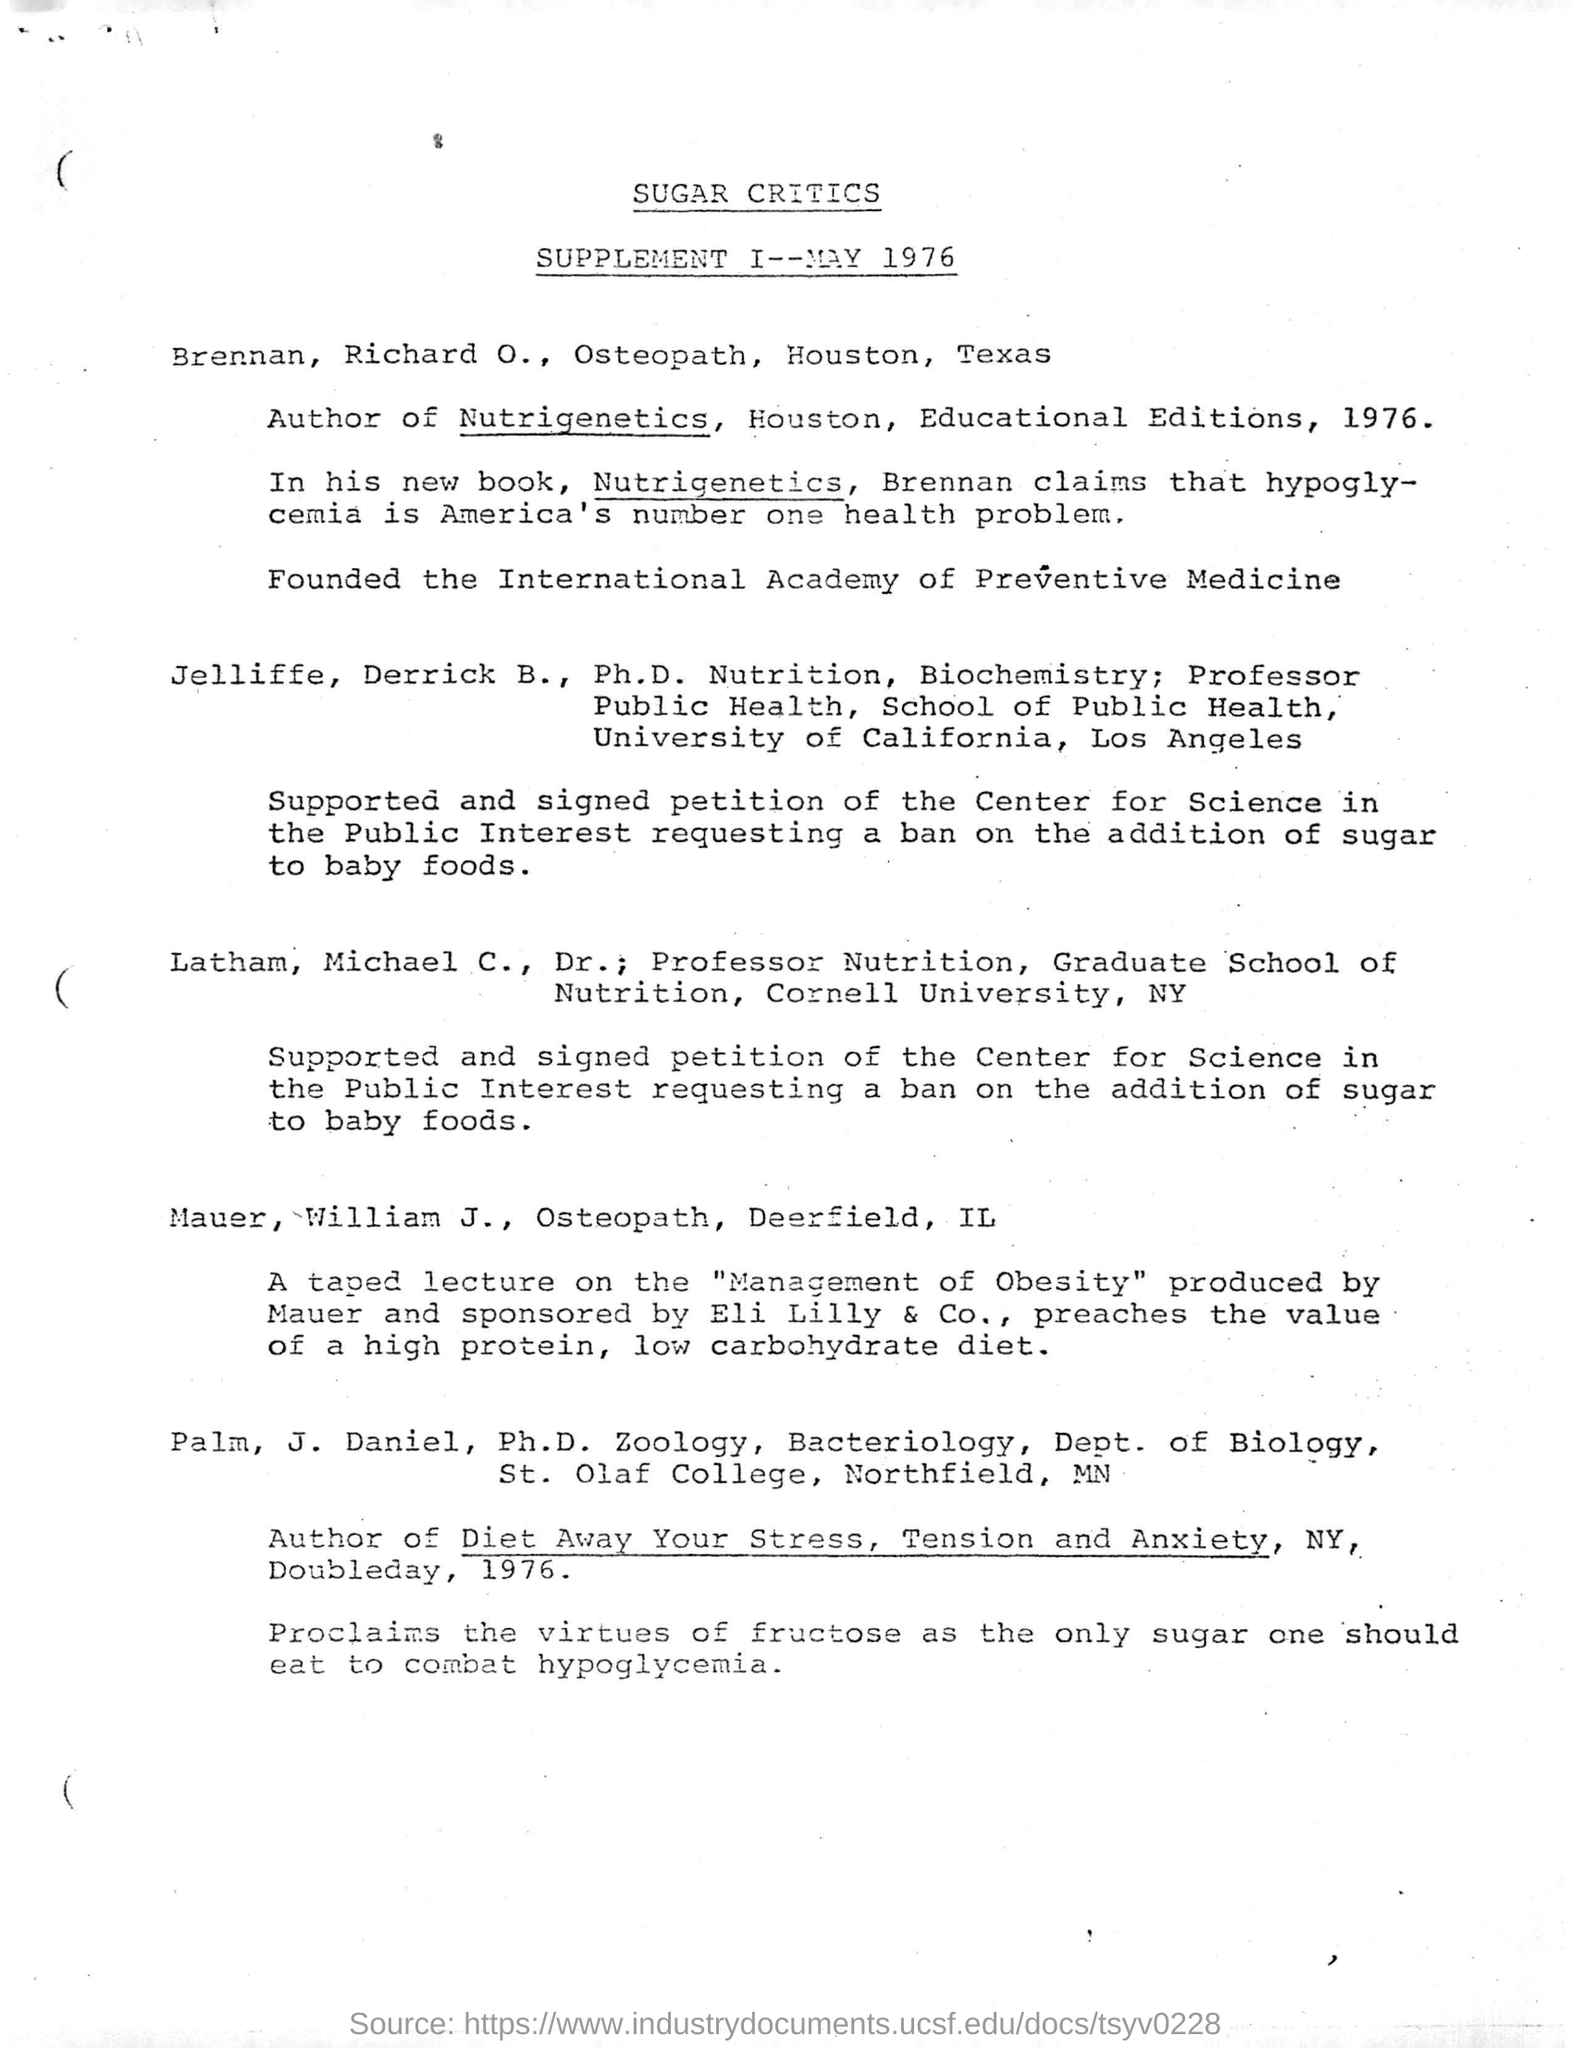Draw attention to some important aspects in this diagram. The heading of this document is 'SUGAR CRITICS.' A taped lecture on the topic of "Management of Obesity" was produced by Mauer. Brennan, who claims that hypoglycemia is America's number one health problem, has stated that it is a significant issue in the United States. The International Academy of Preventive Medicine was founded by Richard O. Brennan, an osteopath. 